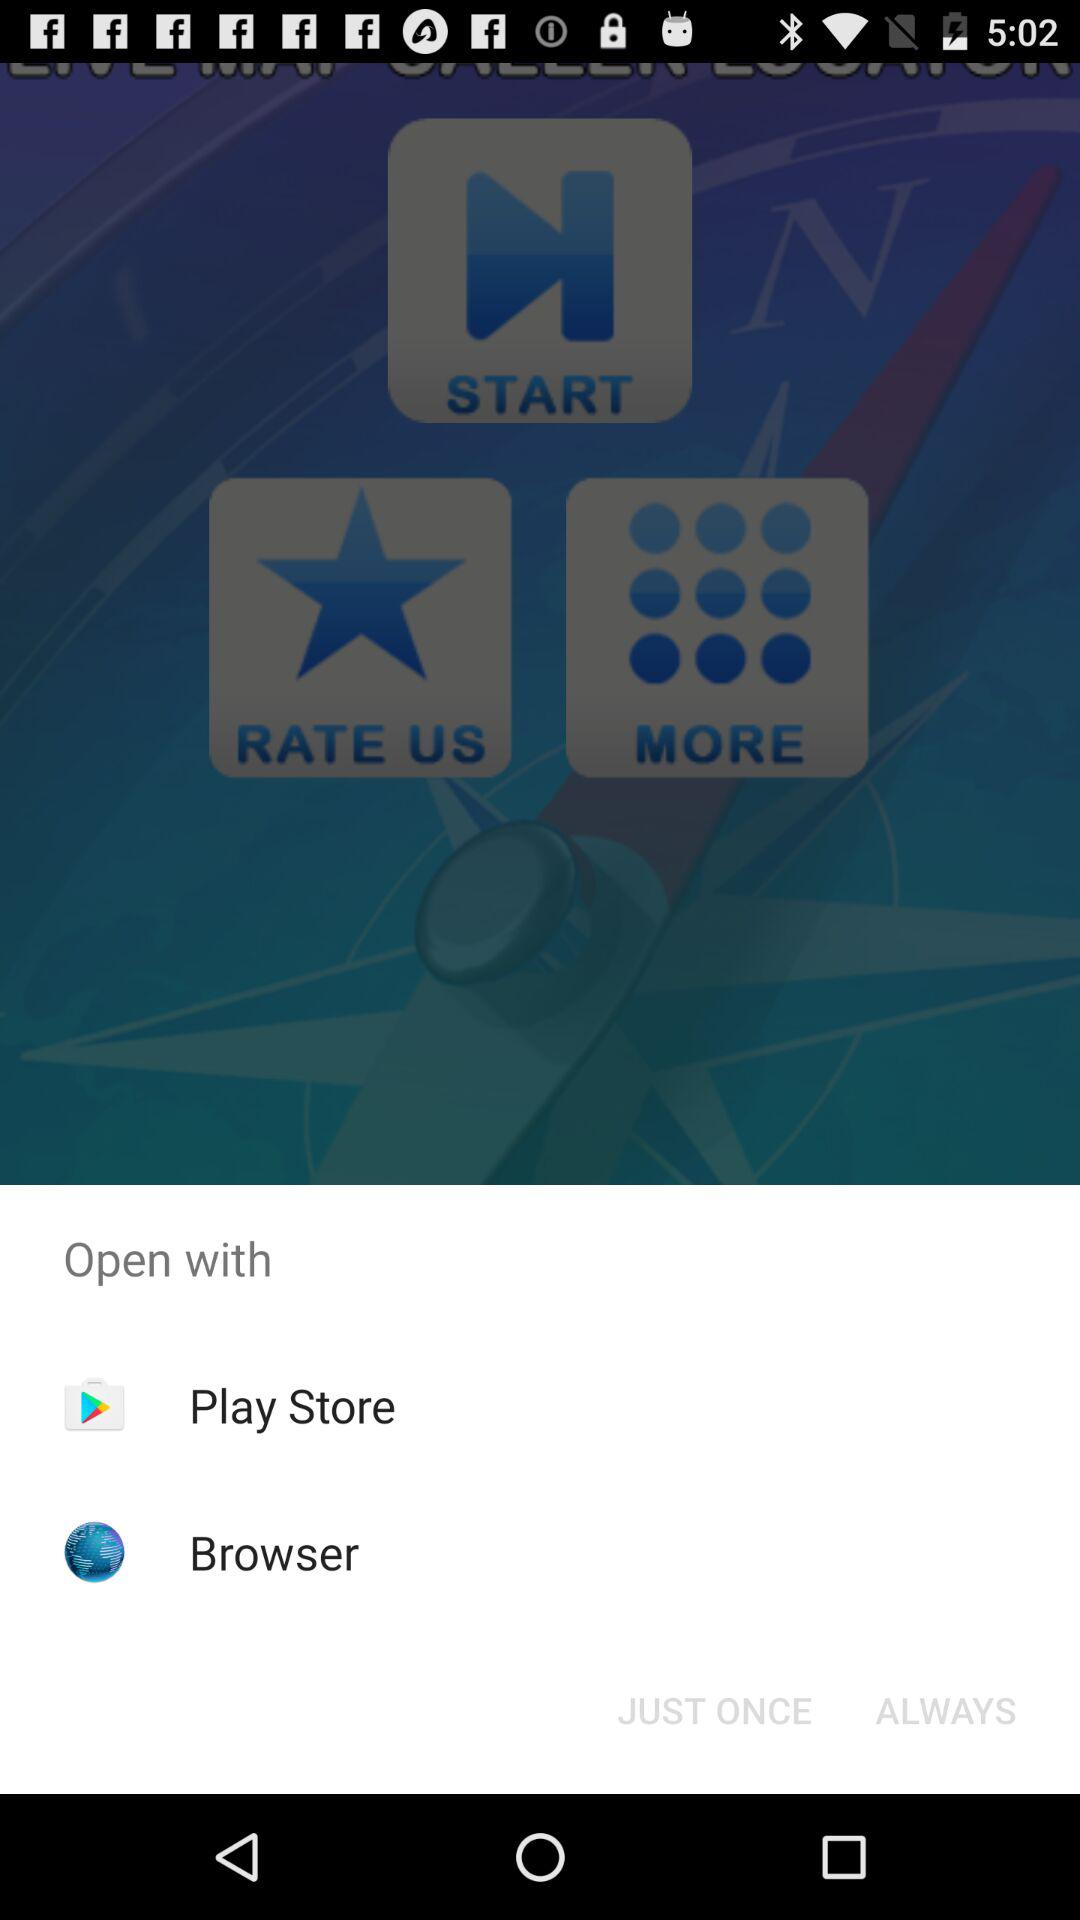What apps can I use to open it? You can open it with "Play Store" and "Browser". 